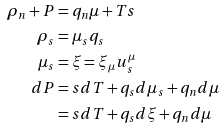<formula> <loc_0><loc_0><loc_500><loc_500>\rho _ { n } + P & = q _ { n } \mu + T s \\ \rho _ { s } & = \mu _ { s } q _ { s } \\ \mu _ { s } & = \xi = \xi _ { \mu } u _ { s } ^ { \mu } \\ d P & = s d T + q _ { s } d \mu _ { s } + q _ { n } d \mu \\ & = s d T + q _ { s } d \xi + q _ { n } d \mu</formula> 